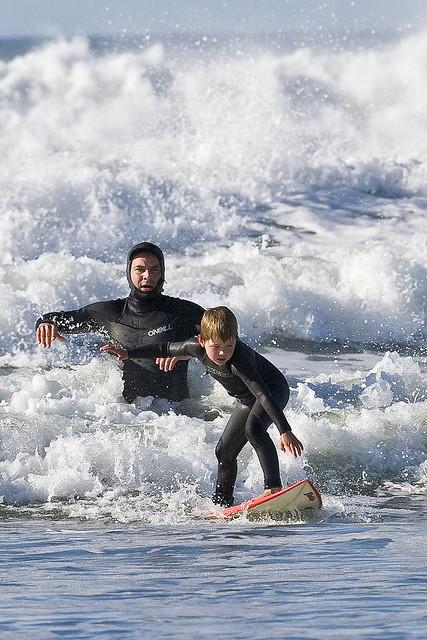Which surfer is more experienced?

Choices:
A) larger one
B) smaller
C) same
D) elderly lady larger one 